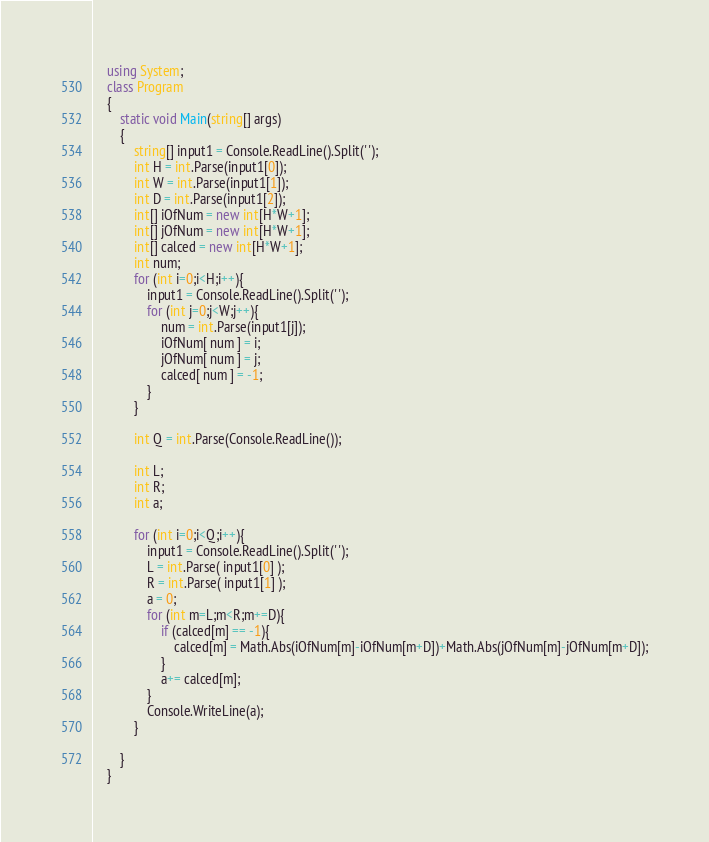Convert code to text. <code><loc_0><loc_0><loc_500><loc_500><_C#_>    using System;
    class Program
    {
    	static void Main(string[] args)
    	{
			string[] input1 = Console.ReadLine().Split(' ');
			int H = int.Parse(input1[0]);
			int W = int.Parse(input1[1]);
			int D = int.Parse(input1[2]);
			int[] iOfNum = new int[H*W+1];
			int[] jOfNum = new int[H*W+1];
			int[] calced = new int[H*W+1];
			int num;
			for (int i=0;i<H;i++){
				input1 = Console.ReadLine().Split(' ');	
				for (int j=0;j<W;j++){
					num = int.Parse(input1[j]);
					iOfNum[ num ] = i;
					jOfNum[ num ] = j;
					calced[ num ] = -1;
				}
			}

			int Q = int.Parse(Console.ReadLine());

			int L;
			int R;
			int a;

			for (int i=0;i<Q;i++){
				input1 = Console.ReadLine().Split(' ');	
				L = int.Parse( input1[0] );
				R = int.Parse( input1[1] );
				a = 0;
				for (int m=L;m<R;m+=D){
					if (calced[m] == -1){
						calced[m] = Math.Abs(iOfNum[m]-iOfNum[m+D])+Math.Abs(jOfNum[m]-jOfNum[m+D]);
					}
					a+= calced[m];
				}
				Console.WriteLine(a);
			}

    	}
    }</code> 